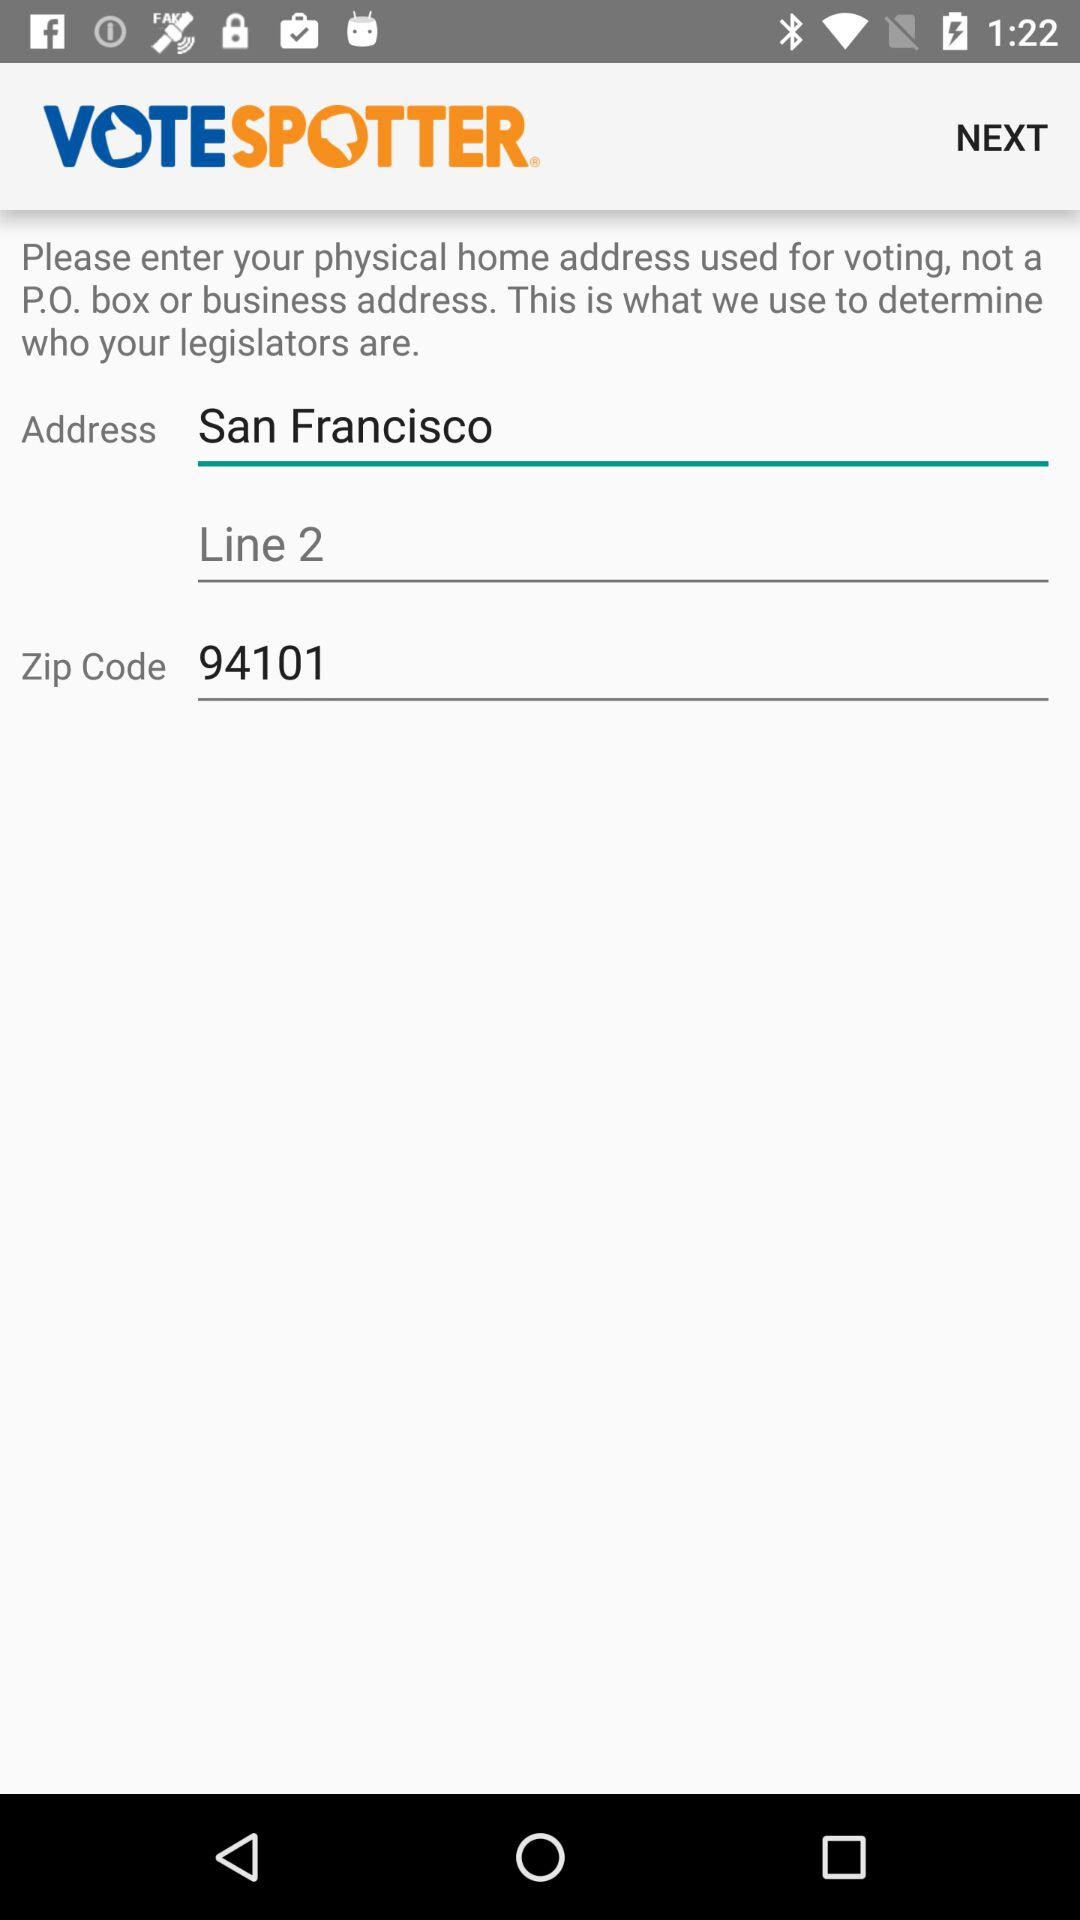What is the line?
When the provided information is insufficient, respond with <no answer>. <no answer> 